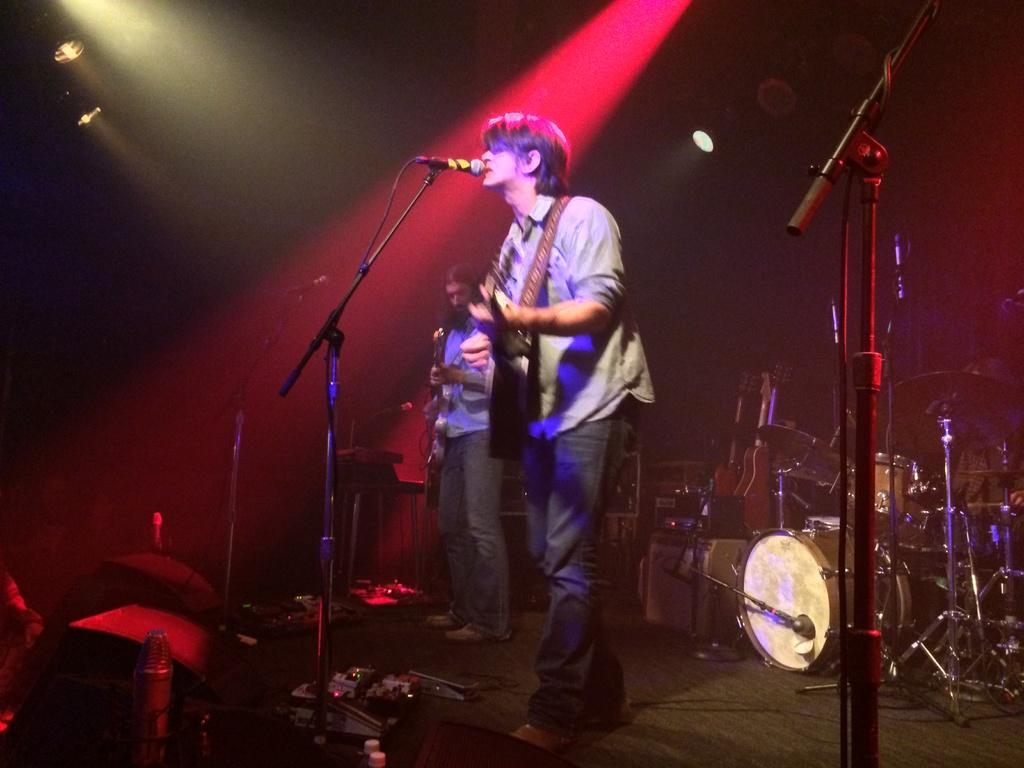Who is the main subject in the image? There is a man in the image. What is the man doing in the image? The man is playing a guitar. What object is present for amplifying sound in the image? There is a microphone in the image. What other musical instruments can be seen in the image? There are musical instruments in the image. What town is visible in the background of the image? There is no town visible in the background of the image. What is the man thinking about while playing the guitar in the image? The image does not provide any information about the man's thoughts or emotions. 